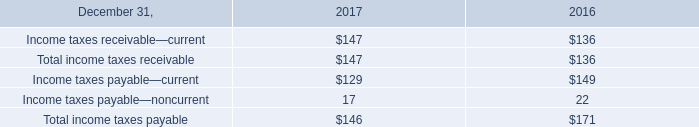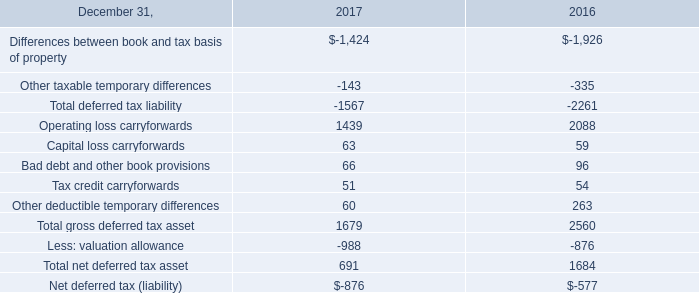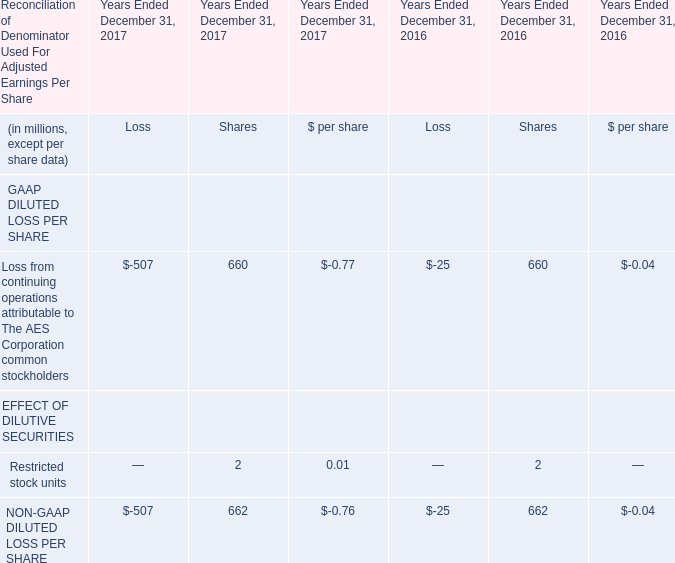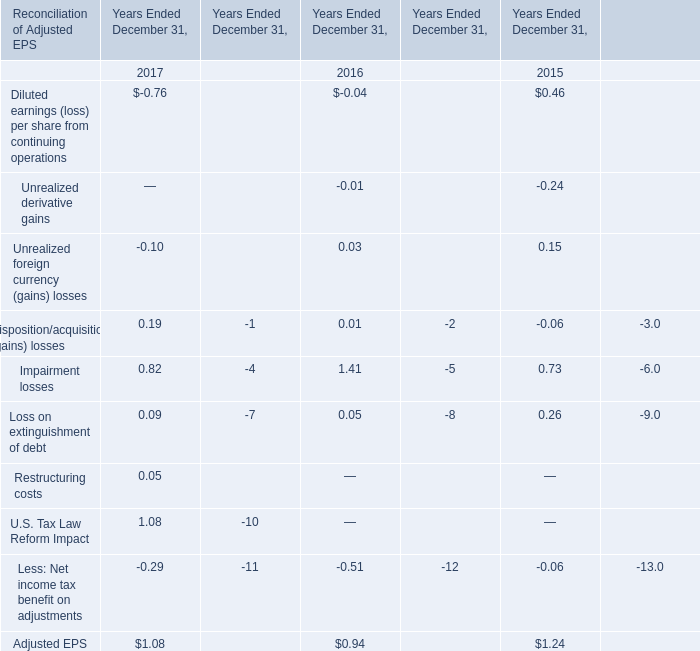What is the growing rate of NON-GAAP DILUTED LOSS PER SHARE in the year with the most Loss from continuing operations attributable to The AES Corporation common stockholders? 
Computations: (((-507 + 662) - (-25 + 662)) / (-25 + 662))
Answer: -0.75667. 